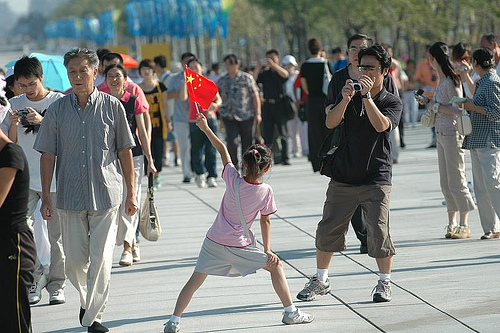<image>
Can you confirm if the man is behind the girl? Yes. From this viewpoint, the man is positioned behind the girl, with the girl partially or fully occluding the man. Is there a man in front of the camera? Yes. The man is positioned in front of the camera, appearing closer to the camera viewpoint. 